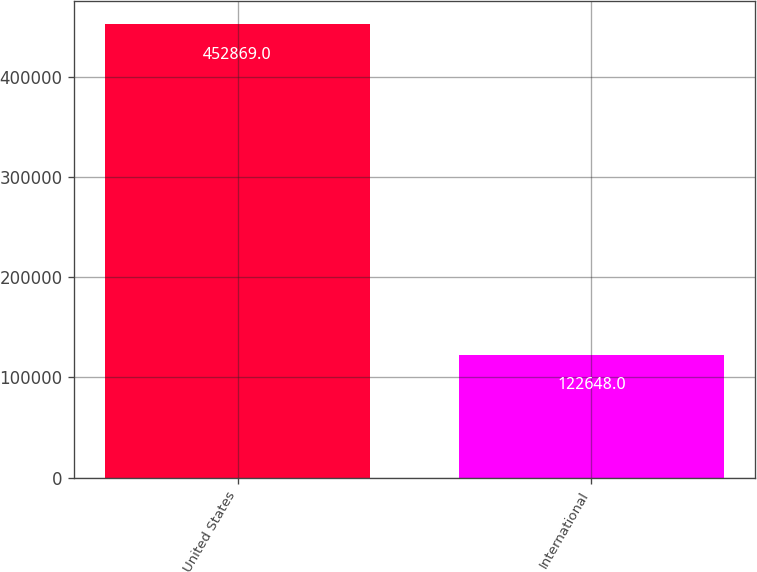Convert chart to OTSL. <chart><loc_0><loc_0><loc_500><loc_500><bar_chart><fcel>United States<fcel>International<nl><fcel>452869<fcel>122648<nl></chart> 